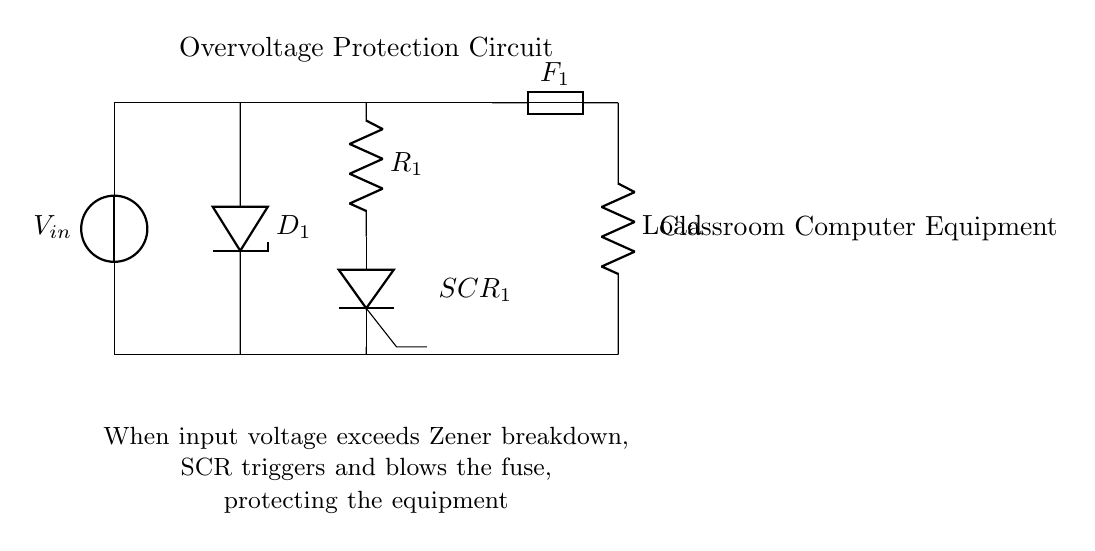What is the main function of the Zener diode in this circuit? The Zener diode, labeled as D1, provides voltage regulation by allowing current to flow in the reverse direction once the voltage exceeds its breakdown voltage, thereby preventing overvoltage conditions.
Answer: Voltage regulation What happens to the fuse when the input voltage exceeds the Zener breakdown? When the input voltage exceeds the breakdown voltage of the Zener diode, the SCR is triggered and causes the fuse to blow, cutting off the flow of current to the load and protecting the equipment from damage.
Answer: Fuse blows What component protects the load from overvoltage? The Zener diode D1 is the component that protects the load by regulating the voltage and preventing excess voltage from reaching the load.
Answer: Zener diode What is the role of the SCR in this circuit? The SCR, which stands for silicon-controlled rectifier, acts as a switch that triggers to connect the load to ground when the overvoltage condition is detected, helping to disconnect the equipment from the source.
Answer: Switch How is the load connected in the circuit? The load is connected in series with the fuse at the output side, meaning it receives the power after the protective components manage the input voltage.
Answer: Series What is the function of the resistor R1 in this circuit? Resistor R1 limits the current flowing through the circuit under normal conditions and plays a crucial role in setting the current for the Zener diode to function correctly.
Answer: Current limitation 